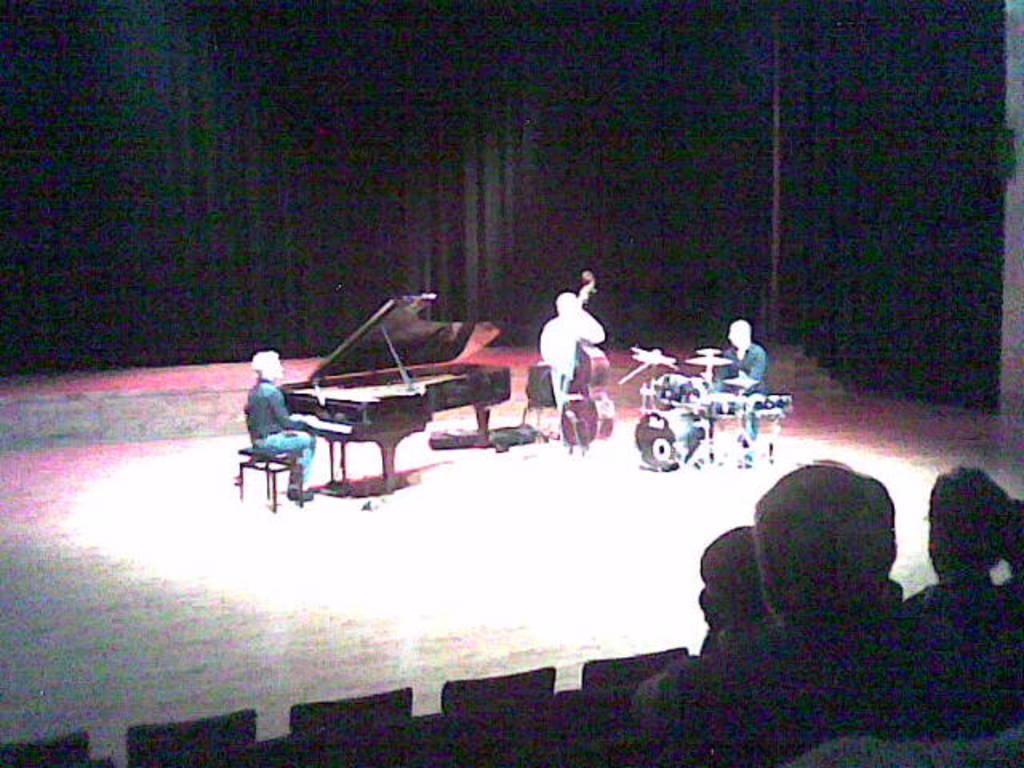Please provide a concise description of this image. In this image there is a man who is sitting in the chair near the piano and a man standing and playing a guitar and another man sitting in chair and playing the drums and at the back ground there is a big black curtain and here there are some group of people sitting in the chairs. 